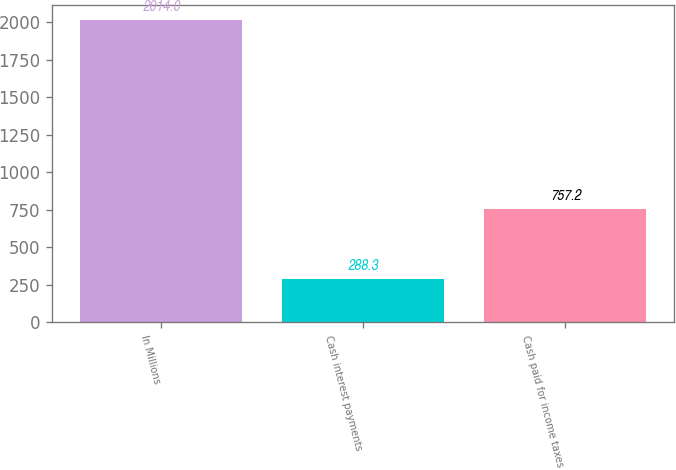Convert chart to OTSL. <chart><loc_0><loc_0><loc_500><loc_500><bar_chart><fcel>In Millions<fcel>Cash interest payments<fcel>Cash paid for income taxes<nl><fcel>2014<fcel>288.3<fcel>757.2<nl></chart> 